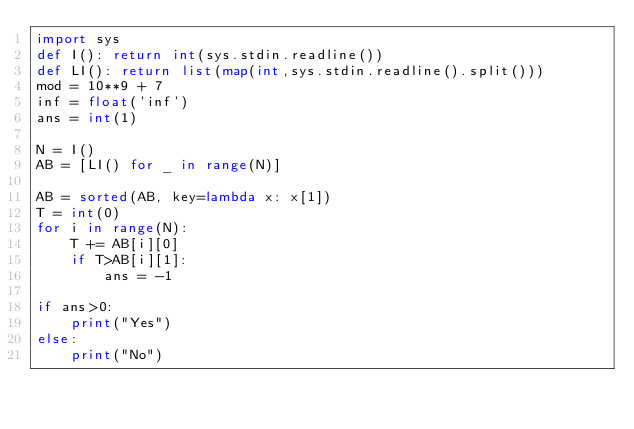Convert code to text. <code><loc_0><loc_0><loc_500><loc_500><_Python_>import sys
def I(): return int(sys.stdin.readline())
def LI(): return list(map(int,sys.stdin.readline().split()))
mod = 10**9 + 7
inf = float('inf')
ans = int(1)

N = I()
AB = [LI() for _ in range(N)]

AB = sorted(AB, key=lambda x: x[1])
T = int(0)
for i in range(N):
    T += AB[i][0]
    if T>AB[i][1]:
        ans = -1

if ans>0:
    print("Yes")
else:
    print("No")</code> 